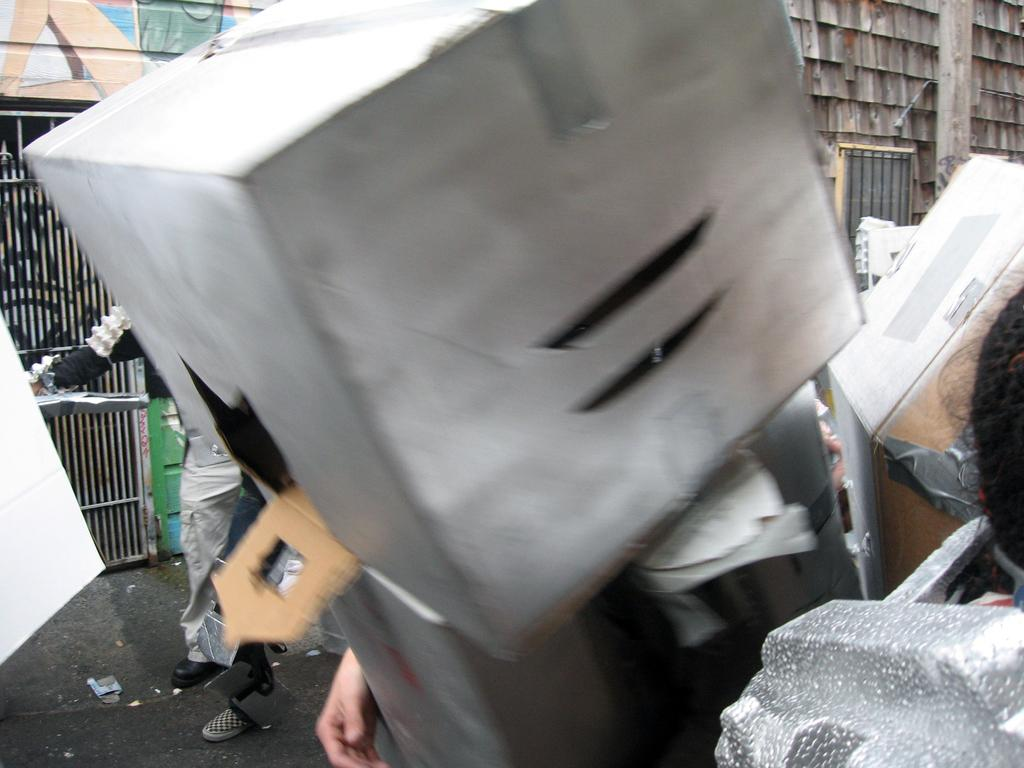What objects can be seen in the image? There are boxes in the image. Where is the person located in the image? There is a person standing on the left side of the image. What part of a person's body is visible at the bottom of the image? There is a person's hand at the bottom of the image. What type of ant can be seen crawling on the person's tongue in the image? There is no ant present in the image, and no person's tongue is visible. 